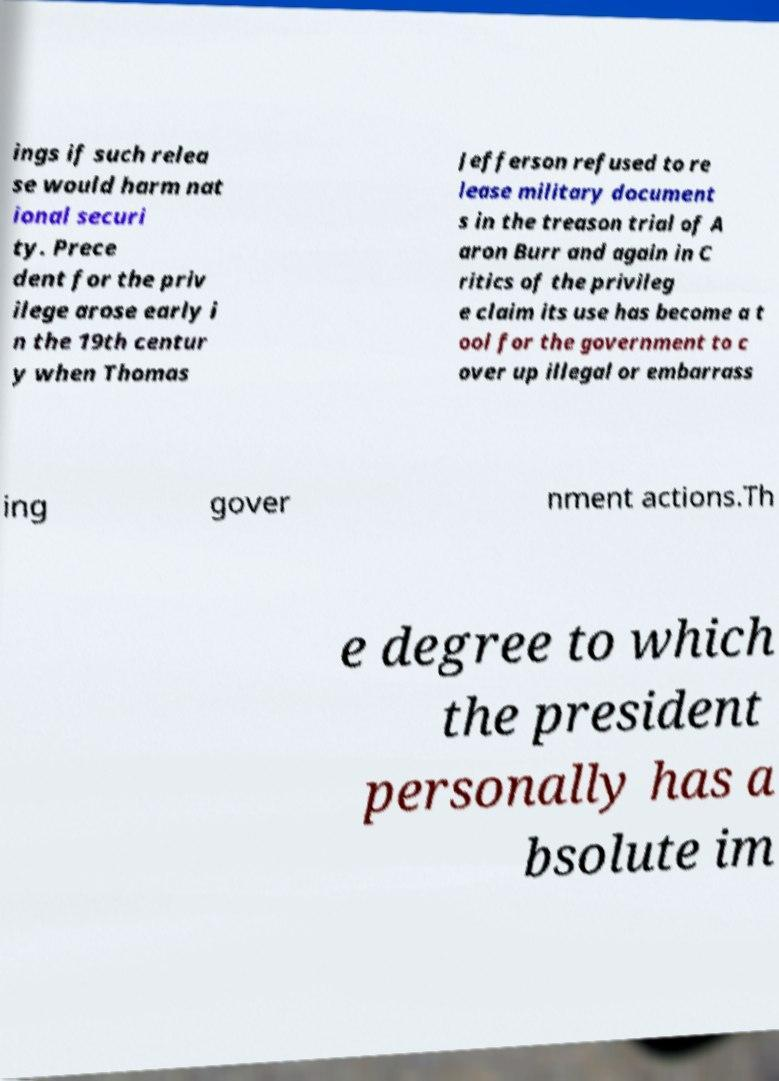For documentation purposes, I need the text within this image transcribed. Could you provide that? ings if such relea se would harm nat ional securi ty. Prece dent for the priv ilege arose early i n the 19th centur y when Thomas Jefferson refused to re lease military document s in the treason trial of A aron Burr and again in C ritics of the privileg e claim its use has become a t ool for the government to c over up illegal or embarrass ing gover nment actions.Th e degree to which the president personally has a bsolute im 